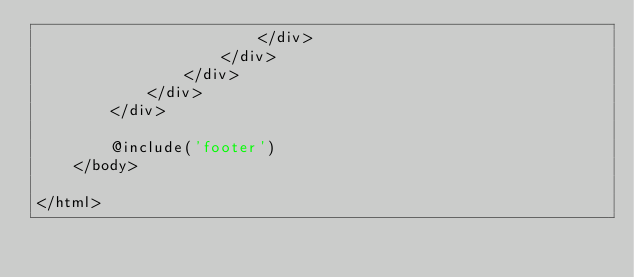<code> <loc_0><loc_0><loc_500><loc_500><_PHP_>                        </div>
                    </div>
                </div>
            </div>
        </div>

        @include('footer')
    </body>

</html>



        </code> 